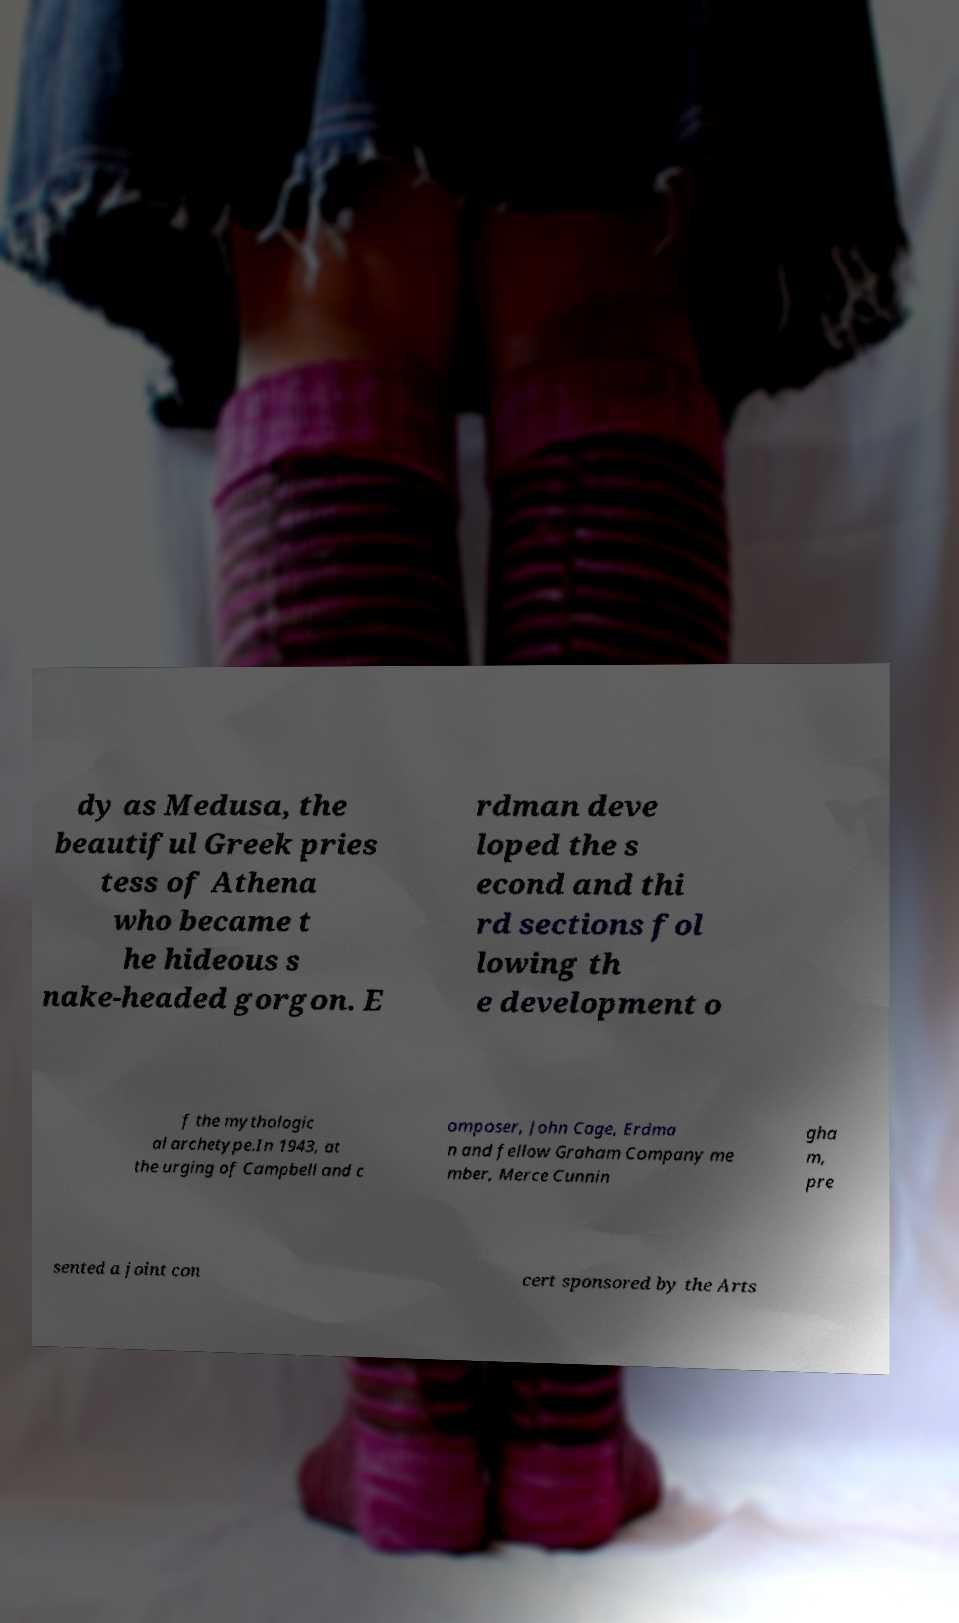Please read and relay the text visible in this image. What does it say? dy as Medusa, the beautiful Greek pries tess of Athena who became t he hideous s nake-headed gorgon. E rdman deve loped the s econd and thi rd sections fol lowing th e development o f the mythologic al archetype.In 1943, at the urging of Campbell and c omposer, John Cage, Erdma n and fellow Graham Company me mber, Merce Cunnin gha m, pre sented a joint con cert sponsored by the Arts 